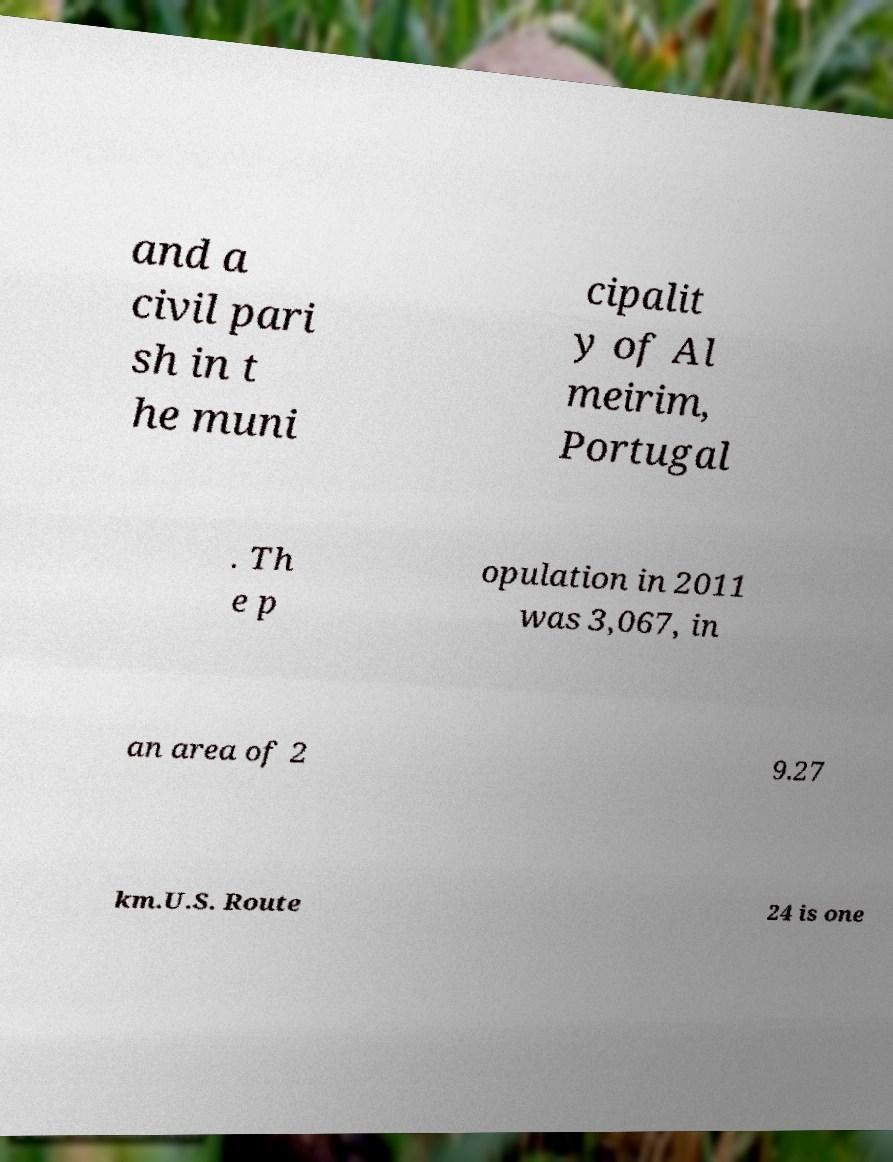There's text embedded in this image that I need extracted. Can you transcribe it verbatim? and a civil pari sh in t he muni cipalit y of Al meirim, Portugal . Th e p opulation in 2011 was 3,067, in an area of 2 9.27 km.U.S. Route 24 is one 